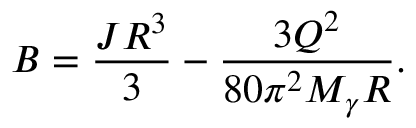Convert formula to latex. <formula><loc_0><loc_0><loc_500><loc_500>B = \frac { J R ^ { 3 } } { 3 } - \frac { 3 Q ^ { 2 } } { 8 0 \pi ^ { 2 } M _ { \gamma } R } .</formula> 